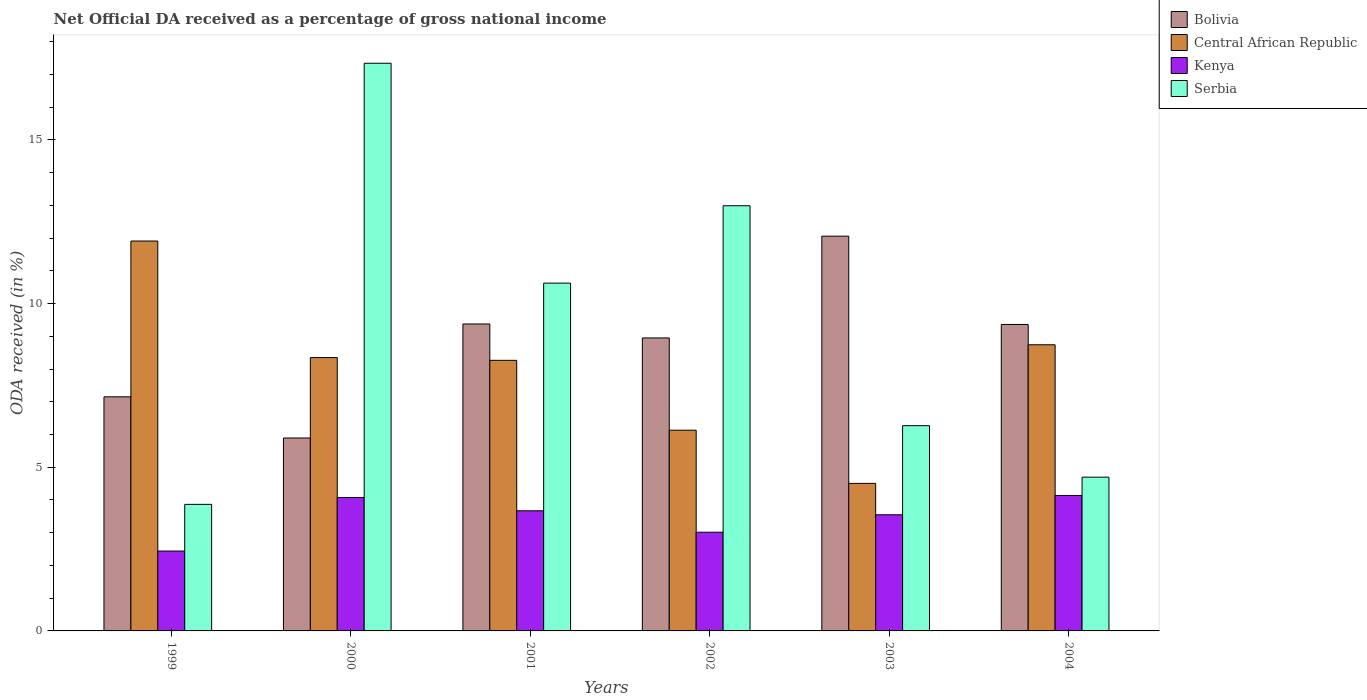How many different coloured bars are there?
Your response must be concise. 4. How many bars are there on the 1st tick from the left?
Your answer should be very brief. 4. What is the label of the 3rd group of bars from the left?
Provide a succinct answer. 2001. In how many cases, is the number of bars for a given year not equal to the number of legend labels?
Provide a succinct answer. 0. What is the net official DA received in Serbia in 2004?
Provide a succinct answer. 4.7. Across all years, what is the maximum net official DA received in Central African Republic?
Your answer should be compact. 11.91. Across all years, what is the minimum net official DA received in Bolivia?
Ensure brevity in your answer.  5.89. In which year was the net official DA received in Central African Republic minimum?
Offer a very short reply. 2003. What is the total net official DA received in Central African Republic in the graph?
Your response must be concise. 47.91. What is the difference between the net official DA received in Bolivia in 2000 and that in 2002?
Make the answer very short. -3.06. What is the difference between the net official DA received in Central African Republic in 2003 and the net official DA received in Kenya in 1999?
Provide a succinct answer. 2.07. What is the average net official DA received in Central African Republic per year?
Your answer should be compact. 7.99. In the year 2000, what is the difference between the net official DA received in Bolivia and net official DA received in Central African Republic?
Make the answer very short. -2.46. What is the ratio of the net official DA received in Serbia in 2003 to that in 2004?
Your response must be concise. 1.33. Is the net official DA received in Central African Republic in 1999 less than that in 2001?
Provide a short and direct response. No. What is the difference between the highest and the second highest net official DA received in Kenya?
Ensure brevity in your answer.  0.06. What is the difference between the highest and the lowest net official DA received in Kenya?
Ensure brevity in your answer.  1.7. Is the sum of the net official DA received in Bolivia in 2000 and 2002 greater than the maximum net official DA received in Kenya across all years?
Your answer should be compact. Yes. Is it the case that in every year, the sum of the net official DA received in Serbia and net official DA received in Central African Republic is greater than the sum of net official DA received in Bolivia and net official DA received in Kenya?
Your answer should be compact. No. What does the 2nd bar from the left in 2003 represents?
Keep it short and to the point. Central African Republic. What does the 1st bar from the right in 2000 represents?
Provide a succinct answer. Serbia. Is it the case that in every year, the sum of the net official DA received in Serbia and net official DA received in Kenya is greater than the net official DA received in Bolivia?
Offer a very short reply. No. Are all the bars in the graph horizontal?
Keep it short and to the point. No. Are the values on the major ticks of Y-axis written in scientific E-notation?
Give a very brief answer. No. Does the graph contain any zero values?
Provide a short and direct response. No. Where does the legend appear in the graph?
Keep it short and to the point. Top right. How are the legend labels stacked?
Provide a short and direct response. Vertical. What is the title of the graph?
Keep it short and to the point. Net Official DA received as a percentage of gross national income. What is the label or title of the Y-axis?
Make the answer very short. ODA received (in %). What is the ODA received (in %) of Bolivia in 1999?
Keep it short and to the point. 7.15. What is the ODA received (in %) in Central African Republic in 1999?
Offer a terse response. 11.91. What is the ODA received (in %) in Kenya in 1999?
Your answer should be compact. 2.44. What is the ODA received (in %) in Serbia in 1999?
Make the answer very short. 3.87. What is the ODA received (in %) of Bolivia in 2000?
Provide a succinct answer. 5.89. What is the ODA received (in %) of Central African Republic in 2000?
Provide a short and direct response. 8.35. What is the ODA received (in %) of Kenya in 2000?
Offer a very short reply. 4.08. What is the ODA received (in %) of Serbia in 2000?
Your answer should be compact. 17.34. What is the ODA received (in %) of Bolivia in 2001?
Make the answer very short. 9.38. What is the ODA received (in %) in Central African Republic in 2001?
Provide a short and direct response. 8.27. What is the ODA received (in %) in Kenya in 2001?
Your response must be concise. 3.67. What is the ODA received (in %) in Serbia in 2001?
Your answer should be very brief. 10.63. What is the ODA received (in %) of Bolivia in 2002?
Make the answer very short. 8.95. What is the ODA received (in %) of Central African Republic in 2002?
Your answer should be compact. 6.13. What is the ODA received (in %) in Kenya in 2002?
Provide a succinct answer. 3.02. What is the ODA received (in %) of Serbia in 2002?
Give a very brief answer. 12.99. What is the ODA received (in %) in Bolivia in 2003?
Make the answer very short. 12.06. What is the ODA received (in %) of Central African Republic in 2003?
Make the answer very short. 4.51. What is the ODA received (in %) of Kenya in 2003?
Provide a succinct answer. 3.55. What is the ODA received (in %) of Serbia in 2003?
Keep it short and to the point. 6.27. What is the ODA received (in %) of Bolivia in 2004?
Provide a succinct answer. 9.36. What is the ODA received (in %) in Central African Republic in 2004?
Your answer should be compact. 8.74. What is the ODA received (in %) in Kenya in 2004?
Your answer should be very brief. 4.14. What is the ODA received (in %) in Serbia in 2004?
Provide a succinct answer. 4.7. Across all years, what is the maximum ODA received (in %) of Bolivia?
Your answer should be very brief. 12.06. Across all years, what is the maximum ODA received (in %) of Central African Republic?
Keep it short and to the point. 11.91. Across all years, what is the maximum ODA received (in %) in Kenya?
Make the answer very short. 4.14. Across all years, what is the maximum ODA received (in %) of Serbia?
Provide a succinct answer. 17.34. Across all years, what is the minimum ODA received (in %) of Bolivia?
Keep it short and to the point. 5.89. Across all years, what is the minimum ODA received (in %) of Central African Republic?
Provide a succinct answer. 4.51. Across all years, what is the minimum ODA received (in %) in Kenya?
Ensure brevity in your answer.  2.44. Across all years, what is the minimum ODA received (in %) of Serbia?
Your answer should be compact. 3.87. What is the total ODA received (in %) of Bolivia in the graph?
Provide a succinct answer. 52.8. What is the total ODA received (in %) of Central African Republic in the graph?
Your answer should be very brief. 47.91. What is the total ODA received (in %) of Kenya in the graph?
Your answer should be very brief. 20.89. What is the total ODA received (in %) in Serbia in the graph?
Provide a short and direct response. 55.8. What is the difference between the ODA received (in %) of Bolivia in 1999 and that in 2000?
Make the answer very short. 1.26. What is the difference between the ODA received (in %) of Central African Republic in 1999 and that in 2000?
Give a very brief answer. 3.56. What is the difference between the ODA received (in %) of Kenya in 1999 and that in 2000?
Provide a short and direct response. -1.64. What is the difference between the ODA received (in %) in Serbia in 1999 and that in 2000?
Your response must be concise. -13.48. What is the difference between the ODA received (in %) in Bolivia in 1999 and that in 2001?
Your answer should be compact. -2.23. What is the difference between the ODA received (in %) in Central African Republic in 1999 and that in 2001?
Give a very brief answer. 3.65. What is the difference between the ODA received (in %) in Kenya in 1999 and that in 2001?
Keep it short and to the point. -1.23. What is the difference between the ODA received (in %) of Serbia in 1999 and that in 2001?
Your answer should be compact. -6.76. What is the difference between the ODA received (in %) of Bolivia in 1999 and that in 2002?
Make the answer very short. -1.8. What is the difference between the ODA received (in %) in Central African Republic in 1999 and that in 2002?
Your response must be concise. 5.78. What is the difference between the ODA received (in %) in Kenya in 1999 and that in 2002?
Offer a very short reply. -0.58. What is the difference between the ODA received (in %) in Serbia in 1999 and that in 2002?
Keep it short and to the point. -9.12. What is the difference between the ODA received (in %) in Bolivia in 1999 and that in 2003?
Offer a very short reply. -4.91. What is the difference between the ODA received (in %) in Central African Republic in 1999 and that in 2003?
Provide a succinct answer. 7.4. What is the difference between the ODA received (in %) of Kenya in 1999 and that in 2003?
Make the answer very short. -1.11. What is the difference between the ODA received (in %) in Serbia in 1999 and that in 2003?
Keep it short and to the point. -2.4. What is the difference between the ODA received (in %) of Bolivia in 1999 and that in 2004?
Offer a terse response. -2.21. What is the difference between the ODA received (in %) of Central African Republic in 1999 and that in 2004?
Make the answer very short. 3.17. What is the difference between the ODA received (in %) of Kenya in 1999 and that in 2004?
Your answer should be very brief. -1.7. What is the difference between the ODA received (in %) in Serbia in 1999 and that in 2004?
Make the answer very short. -0.83. What is the difference between the ODA received (in %) in Bolivia in 2000 and that in 2001?
Offer a very short reply. -3.48. What is the difference between the ODA received (in %) in Central African Republic in 2000 and that in 2001?
Provide a succinct answer. 0.08. What is the difference between the ODA received (in %) in Kenya in 2000 and that in 2001?
Give a very brief answer. 0.41. What is the difference between the ODA received (in %) in Serbia in 2000 and that in 2001?
Give a very brief answer. 6.72. What is the difference between the ODA received (in %) in Bolivia in 2000 and that in 2002?
Your answer should be very brief. -3.06. What is the difference between the ODA received (in %) of Central African Republic in 2000 and that in 2002?
Offer a very short reply. 2.22. What is the difference between the ODA received (in %) in Kenya in 2000 and that in 2002?
Offer a terse response. 1.06. What is the difference between the ODA received (in %) of Serbia in 2000 and that in 2002?
Provide a short and direct response. 4.35. What is the difference between the ODA received (in %) in Bolivia in 2000 and that in 2003?
Offer a very short reply. -6.17. What is the difference between the ODA received (in %) of Central African Republic in 2000 and that in 2003?
Offer a terse response. 3.84. What is the difference between the ODA received (in %) of Kenya in 2000 and that in 2003?
Your answer should be compact. 0.53. What is the difference between the ODA received (in %) in Serbia in 2000 and that in 2003?
Your response must be concise. 11.07. What is the difference between the ODA received (in %) in Bolivia in 2000 and that in 2004?
Your answer should be compact. -3.47. What is the difference between the ODA received (in %) of Central African Republic in 2000 and that in 2004?
Offer a very short reply. -0.39. What is the difference between the ODA received (in %) in Kenya in 2000 and that in 2004?
Keep it short and to the point. -0.06. What is the difference between the ODA received (in %) of Serbia in 2000 and that in 2004?
Your response must be concise. 12.65. What is the difference between the ODA received (in %) in Bolivia in 2001 and that in 2002?
Ensure brevity in your answer.  0.43. What is the difference between the ODA received (in %) in Central African Republic in 2001 and that in 2002?
Keep it short and to the point. 2.13. What is the difference between the ODA received (in %) in Kenya in 2001 and that in 2002?
Offer a terse response. 0.65. What is the difference between the ODA received (in %) in Serbia in 2001 and that in 2002?
Your response must be concise. -2.36. What is the difference between the ODA received (in %) in Bolivia in 2001 and that in 2003?
Offer a terse response. -2.68. What is the difference between the ODA received (in %) in Central African Republic in 2001 and that in 2003?
Offer a very short reply. 3.76. What is the difference between the ODA received (in %) of Kenya in 2001 and that in 2003?
Your response must be concise. 0.12. What is the difference between the ODA received (in %) in Serbia in 2001 and that in 2003?
Provide a succinct answer. 4.36. What is the difference between the ODA received (in %) of Bolivia in 2001 and that in 2004?
Offer a very short reply. 0.02. What is the difference between the ODA received (in %) of Central African Republic in 2001 and that in 2004?
Give a very brief answer. -0.48. What is the difference between the ODA received (in %) in Kenya in 2001 and that in 2004?
Provide a succinct answer. -0.47. What is the difference between the ODA received (in %) in Serbia in 2001 and that in 2004?
Give a very brief answer. 5.93. What is the difference between the ODA received (in %) of Bolivia in 2002 and that in 2003?
Ensure brevity in your answer.  -3.11. What is the difference between the ODA received (in %) in Central African Republic in 2002 and that in 2003?
Your response must be concise. 1.62. What is the difference between the ODA received (in %) of Kenya in 2002 and that in 2003?
Your answer should be very brief. -0.53. What is the difference between the ODA received (in %) of Serbia in 2002 and that in 2003?
Provide a short and direct response. 6.72. What is the difference between the ODA received (in %) in Bolivia in 2002 and that in 2004?
Your answer should be very brief. -0.41. What is the difference between the ODA received (in %) of Central African Republic in 2002 and that in 2004?
Make the answer very short. -2.61. What is the difference between the ODA received (in %) in Kenya in 2002 and that in 2004?
Keep it short and to the point. -1.12. What is the difference between the ODA received (in %) in Serbia in 2002 and that in 2004?
Give a very brief answer. 8.29. What is the difference between the ODA received (in %) in Bolivia in 2003 and that in 2004?
Provide a short and direct response. 2.7. What is the difference between the ODA received (in %) of Central African Republic in 2003 and that in 2004?
Your response must be concise. -4.24. What is the difference between the ODA received (in %) of Kenya in 2003 and that in 2004?
Offer a terse response. -0.59. What is the difference between the ODA received (in %) in Serbia in 2003 and that in 2004?
Ensure brevity in your answer.  1.57. What is the difference between the ODA received (in %) of Bolivia in 1999 and the ODA received (in %) of Central African Republic in 2000?
Make the answer very short. -1.2. What is the difference between the ODA received (in %) in Bolivia in 1999 and the ODA received (in %) in Kenya in 2000?
Provide a succinct answer. 3.08. What is the difference between the ODA received (in %) in Bolivia in 1999 and the ODA received (in %) in Serbia in 2000?
Provide a succinct answer. -10.19. What is the difference between the ODA received (in %) of Central African Republic in 1999 and the ODA received (in %) of Kenya in 2000?
Offer a terse response. 7.84. What is the difference between the ODA received (in %) of Central African Republic in 1999 and the ODA received (in %) of Serbia in 2000?
Provide a short and direct response. -5.43. What is the difference between the ODA received (in %) in Kenya in 1999 and the ODA received (in %) in Serbia in 2000?
Your answer should be very brief. -14.9. What is the difference between the ODA received (in %) of Bolivia in 1999 and the ODA received (in %) of Central African Republic in 2001?
Offer a very short reply. -1.11. What is the difference between the ODA received (in %) in Bolivia in 1999 and the ODA received (in %) in Kenya in 2001?
Your response must be concise. 3.48. What is the difference between the ODA received (in %) in Bolivia in 1999 and the ODA received (in %) in Serbia in 2001?
Provide a succinct answer. -3.47. What is the difference between the ODA received (in %) in Central African Republic in 1999 and the ODA received (in %) in Kenya in 2001?
Make the answer very short. 8.24. What is the difference between the ODA received (in %) of Central African Republic in 1999 and the ODA received (in %) of Serbia in 2001?
Provide a succinct answer. 1.29. What is the difference between the ODA received (in %) of Kenya in 1999 and the ODA received (in %) of Serbia in 2001?
Offer a terse response. -8.19. What is the difference between the ODA received (in %) of Bolivia in 1999 and the ODA received (in %) of Central African Republic in 2002?
Your answer should be very brief. 1.02. What is the difference between the ODA received (in %) in Bolivia in 1999 and the ODA received (in %) in Kenya in 2002?
Your response must be concise. 4.14. What is the difference between the ODA received (in %) of Bolivia in 1999 and the ODA received (in %) of Serbia in 2002?
Your answer should be very brief. -5.84. What is the difference between the ODA received (in %) of Central African Republic in 1999 and the ODA received (in %) of Kenya in 2002?
Your response must be concise. 8.9. What is the difference between the ODA received (in %) in Central African Republic in 1999 and the ODA received (in %) in Serbia in 2002?
Ensure brevity in your answer.  -1.08. What is the difference between the ODA received (in %) in Kenya in 1999 and the ODA received (in %) in Serbia in 2002?
Provide a short and direct response. -10.55. What is the difference between the ODA received (in %) in Bolivia in 1999 and the ODA received (in %) in Central African Republic in 2003?
Make the answer very short. 2.64. What is the difference between the ODA received (in %) of Bolivia in 1999 and the ODA received (in %) of Kenya in 2003?
Offer a terse response. 3.6. What is the difference between the ODA received (in %) of Bolivia in 1999 and the ODA received (in %) of Serbia in 2003?
Offer a terse response. 0.88. What is the difference between the ODA received (in %) of Central African Republic in 1999 and the ODA received (in %) of Kenya in 2003?
Provide a short and direct response. 8.36. What is the difference between the ODA received (in %) of Central African Republic in 1999 and the ODA received (in %) of Serbia in 2003?
Offer a very short reply. 5.64. What is the difference between the ODA received (in %) in Kenya in 1999 and the ODA received (in %) in Serbia in 2003?
Your answer should be very brief. -3.83. What is the difference between the ODA received (in %) of Bolivia in 1999 and the ODA received (in %) of Central African Republic in 2004?
Offer a terse response. -1.59. What is the difference between the ODA received (in %) in Bolivia in 1999 and the ODA received (in %) in Kenya in 2004?
Ensure brevity in your answer.  3.01. What is the difference between the ODA received (in %) of Bolivia in 1999 and the ODA received (in %) of Serbia in 2004?
Offer a very short reply. 2.45. What is the difference between the ODA received (in %) of Central African Republic in 1999 and the ODA received (in %) of Kenya in 2004?
Make the answer very short. 7.77. What is the difference between the ODA received (in %) in Central African Republic in 1999 and the ODA received (in %) in Serbia in 2004?
Give a very brief answer. 7.21. What is the difference between the ODA received (in %) of Kenya in 1999 and the ODA received (in %) of Serbia in 2004?
Offer a terse response. -2.26. What is the difference between the ODA received (in %) in Bolivia in 2000 and the ODA received (in %) in Central African Republic in 2001?
Keep it short and to the point. -2.37. What is the difference between the ODA received (in %) in Bolivia in 2000 and the ODA received (in %) in Kenya in 2001?
Provide a short and direct response. 2.22. What is the difference between the ODA received (in %) in Bolivia in 2000 and the ODA received (in %) in Serbia in 2001?
Provide a succinct answer. -4.73. What is the difference between the ODA received (in %) in Central African Republic in 2000 and the ODA received (in %) in Kenya in 2001?
Provide a succinct answer. 4.68. What is the difference between the ODA received (in %) in Central African Republic in 2000 and the ODA received (in %) in Serbia in 2001?
Provide a succinct answer. -2.28. What is the difference between the ODA received (in %) in Kenya in 2000 and the ODA received (in %) in Serbia in 2001?
Ensure brevity in your answer.  -6.55. What is the difference between the ODA received (in %) in Bolivia in 2000 and the ODA received (in %) in Central African Republic in 2002?
Make the answer very short. -0.24. What is the difference between the ODA received (in %) in Bolivia in 2000 and the ODA received (in %) in Kenya in 2002?
Provide a short and direct response. 2.88. What is the difference between the ODA received (in %) in Bolivia in 2000 and the ODA received (in %) in Serbia in 2002?
Your answer should be compact. -7.1. What is the difference between the ODA received (in %) of Central African Republic in 2000 and the ODA received (in %) of Kenya in 2002?
Offer a terse response. 5.34. What is the difference between the ODA received (in %) in Central African Republic in 2000 and the ODA received (in %) in Serbia in 2002?
Provide a succinct answer. -4.64. What is the difference between the ODA received (in %) of Kenya in 2000 and the ODA received (in %) of Serbia in 2002?
Offer a terse response. -8.91. What is the difference between the ODA received (in %) of Bolivia in 2000 and the ODA received (in %) of Central African Republic in 2003?
Provide a succinct answer. 1.39. What is the difference between the ODA received (in %) in Bolivia in 2000 and the ODA received (in %) in Kenya in 2003?
Provide a succinct answer. 2.35. What is the difference between the ODA received (in %) in Bolivia in 2000 and the ODA received (in %) in Serbia in 2003?
Offer a very short reply. -0.38. What is the difference between the ODA received (in %) of Central African Republic in 2000 and the ODA received (in %) of Kenya in 2003?
Make the answer very short. 4.8. What is the difference between the ODA received (in %) in Central African Republic in 2000 and the ODA received (in %) in Serbia in 2003?
Offer a very short reply. 2.08. What is the difference between the ODA received (in %) of Kenya in 2000 and the ODA received (in %) of Serbia in 2003?
Provide a succinct answer. -2.19. What is the difference between the ODA received (in %) in Bolivia in 2000 and the ODA received (in %) in Central African Republic in 2004?
Provide a short and direct response. -2.85. What is the difference between the ODA received (in %) of Bolivia in 2000 and the ODA received (in %) of Kenya in 2004?
Your answer should be compact. 1.76. What is the difference between the ODA received (in %) in Bolivia in 2000 and the ODA received (in %) in Serbia in 2004?
Make the answer very short. 1.2. What is the difference between the ODA received (in %) in Central African Republic in 2000 and the ODA received (in %) in Kenya in 2004?
Offer a very short reply. 4.21. What is the difference between the ODA received (in %) of Central African Republic in 2000 and the ODA received (in %) of Serbia in 2004?
Keep it short and to the point. 3.65. What is the difference between the ODA received (in %) of Kenya in 2000 and the ODA received (in %) of Serbia in 2004?
Ensure brevity in your answer.  -0.62. What is the difference between the ODA received (in %) in Bolivia in 2001 and the ODA received (in %) in Central African Republic in 2002?
Provide a succinct answer. 3.25. What is the difference between the ODA received (in %) of Bolivia in 2001 and the ODA received (in %) of Kenya in 2002?
Your answer should be compact. 6.36. What is the difference between the ODA received (in %) of Bolivia in 2001 and the ODA received (in %) of Serbia in 2002?
Keep it short and to the point. -3.61. What is the difference between the ODA received (in %) in Central African Republic in 2001 and the ODA received (in %) in Kenya in 2002?
Your answer should be very brief. 5.25. What is the difference between the ODA received (in %) of Central African Republic in 2001 and the ODA received (in %) of Serbia in 2002?
Ensure brevity in your answer.  -4.72. What is the difference between the ODA received (in %) of Kenya in 2001 and the ODA received (in %) of Serbia in 2002?
Provide a short and direct response. -9.32. What is the difference between the ODA received (in %) of Bolivia in 2001 and the ODA received (in %) of Central African Republic in 2003?
Your answer should be compact. 4.87. What is the difference between the ODA received (in %) in Bolivia in 2001 and the ODA received (in %) in Kenya in 2003?
Provide a short and direct response. 5.83. What is the difference between the ODA received (in %) of Bolivia in 2001 and the ODA received (in %) of Serbia in 2003?
Give a very brief answer. 3.11. What is the difference between the ODA received (in %) of Central African Republic in 2001 and the ODA received (in %) of Kenya in 2003?
Give a very brief answer. 4.72. What is the difference between the ODA received (in %) of Central African Republic in 2001 and the ODA received (in %) of Serbia in 2003?
Ensure brevity in your answer.  2. What is the difference between the ODA received (in %) in Kenya in 2001 and the ODA received (in %) in Serbia in 2003?
Provide a short and direct response. -2.6. What is the difference between the ODA received (in %) in Bolivia in 2001 and the ODA received (in %) in Central African Republic in 2004?
Keep it short and to the point. 0.64. What is the difference between the ODA received (in %) in Bolivia in 2001 and the ODA received (in %) in Kenya in 2004?
Provide a short and direct response. 5.24. What is the difference between the ODA received (in %) of Bolivia in 2001 and the ODA received (in %) of Serbia in 2004?
Your answer should be compact. 4.68. What is the difference between the ODA received (in %) of Central African Republic in 2001 and the ODA received (in %) of Kenya in 2004?
Your response must be concise. 4.13. What is the difference between the ODA received (in %) of Central African Republic in 2001 and the ODA received (in %) of Serbia in 2004?
Your answer should be compact. 3.57. What is the difference between the ODA received (in %) in Kenya in 2001 and the ODA received (in %) in Serbia in 2004?
Ensure brevity in your answer.  -1.03. What is the difference between the ODA received (in %) in Bolivia in 2002 and the ODA received (in %) in Central African Republic in 2003?
Give a very brief answer. 4.44. What is the difference between the ODA received (in %) in Bolivia in 2002 and the ODA received (in %) in Kenya in 2003?
Give a very brief answer. 5.4. What is the difference between the ODA received (in %) in Bolivia in 2002 and the ODA received (in %) in Serbia in 2003?
Provide a succinct answer. 2.68. What is the difference between the ODA received (in %) in Central African Republic in 2002 and the ODA received (in %) in Kenya in 2003?
Your answer should be compact. 2.58. What is the difference between the ODA received (in %) in Central African Republic in 2002 and the ODA received (in %) in Serbia in 2003?
Keep it short and to the point. -0.14. What is the difference between the ODA received (in %) in Kenya in 2002 and the ODA received (in %) in Serbia in 2003?
Provide a short and direct response. -3.26. What is the difference between the ODA received (in %) in Bolivia in 2002 and the ODA received (in %) in Central African Republic in 2004?
Your response must be concise. 0.21. What is the difference between the ODA received (in %) of Bolivia in 2002 and the ODA received (in %) of Kenya in 2004?
Make the answer very short. 4.81. What is the difference between the ODA received (in %) of Bolivia in 2002 and the ODA received (in %) of Serbia in 2004?
Offer a terse response. 4.25. What is the difference between the ODA received (in %) of Central African Republic in 2002 and the ODA received (in %) of Kenya in 2004?
Offer a terse response. 1.99. What is the difference between the ODA received (in %) of Central African Republic in 2002 and the ODA received (in %) of Serbia in 2004?
Give a very brief answer. 1.44. What is the difference between the ODA received (in %) of Kenya in 2002 and the ODA received (in %) of Serbia in 2004?
Your response must be concise. -1.68. What is the difference between the ODA received (in %) of Bolivia in 2003 and the ODA received (in %) of Central African Republic in 2004?
Offer a very short reply. 3.32. What is the difference between the ODA received (in %) in Bolivia in 2003 and the ODA received (in %) in Kenya in 2004?
Your answer should be very brief. 7.92. What is the difference between the ODA received (in %) in Bolivia in 2003 and the ODA received (in %) in Serbia in 2004?
Keep it short and to the point. 7.36. What is the difference between the ODA received (in %) of Central African Republic in 2003 and the ODA received (in %) of Kenya in 2004?
Your answer should be very brief. 0.37. What is the difference between the ODA received (in %) in Central African Republic in 2003 and the ODA received (in %) in Serbia in 2004?
Give a very brief answer. -0.19. What is the difference between the ODA received (in %) in Kenya in 2003 and the ODA received (in %) in Serbia in 2004?
Give a very brief answer. -1.15. What is the average ODA received (in %) of Bolivia per year?
Give a very brief answer. 8.8. What is the average ODA received (in %) in Central African Republic per year?
Your answer should be very brief. 7.99. What is the average ODA received (in %) of Kenya per year?
Offer a very short reply. 3.48. What is the average ODA received (in %) in Serbia per year?
Keep it short and to the point. 9.3. In the year 1999, what is the difference between the ODA received (in %) of Bolivia and ODA received (in %) of Central African Republic?
Give a very brief answer. -4.76. In the year 1999, what is the difference between the ODA received (in %) of Bolivia and ODA received (in %) of Kenya?
Give a very brief answer. 4.71. In the year 1999, what is the difference between the ODA received (in %) of Bolivia and ODA received (in %) of Serbia?
Make the answer very short. 3.29. In the year 1999, what is the difference between the ODA received (in %) of Central African Republic and ODA received (in %) of Kenya?
Offer a very short reply. 9.47. In the year 1999, what is the difference between the ODA received (in %) of Central African Republic and ODA received (in %) of Serbia?
Offer a terse response. 8.05. In the year 1999, what is the difference between the ODA received (in %) in Kenya and ODA received (in %) in Serbia?
Make the answer very short. -1.43. In the year 2000, what is the difference between the ODA received (in %) in Bolivia and ODA received (in %) in Central African Republic?
Offer a terse response. -2.46. In the year 2000, what is the difference between the ODA received (in %) of Bolivia and ODA received (in %) of Kenya?
Your response must be concise. 1.82. In the year 2000, what is the difference between the ODA received (in %) of Bolivia and ODA received (in %) of Serbia?
Your response must be concise. -11.45. In the year 2000, what is the difference between the ODA received (in %) in Central African Republic and ODA received (in %) in Kenya?
Keep it short and to the point. 4.27. In the year 2000, what is the difference between the ODA received (in %) in Central African Republic and ODA received (in %) in Serbia?
Keep it short and to the point. -8.99. In the year 2000, what is the difference between the ODA received (in %) of Kenya and ODA received (in %) of Serbia?
Keep it short and to the point. -13.27. In the year 2001, what is the difference between the ODA received (in %) of Bolivia and ODA received (in %) of Central African Republic?
Offer a terse response. 1.11. In the year 2001, what is the difference between the ODA received (in %) in Bolivia and ODA received (in %) in Kenya?
Provide a succinct answer. 5.71. In the year 2001, what is the difference between the ODA received (in %) of Bolivia and ODA received (in %) of Serbia?
Make the answer very short. -1.25. In the year 2001, what is the difference between the ODA received (in %) of Central African Republic and ODA received (in %) of Kenya?
Your response must be concise. 4.6. In the year 2001, what is the difference between the ODA received (in %) of Central African Republic and ODA received (in %) of Serbia?
Give a very brief answer. -2.36. In the year 2001, what is the difference between the ODA received (in %) in Kenya and ODA received (in %) in Serbia?
Make the answer very short. -6.96. In the year 2002, what is the difference between the ODA received (in %) of Bolivia and ODA received (in %) of Central African Republic?
Provide a short and direct response. 2.82. In the year 2002, what is the difference between the ODA received (in %) in Bolivia and ODA received (in %) in Kenya?
Keep it short and to the point. 5.94. In the year 2002, what is the difference between the ODA received (in %) of Bolivia and ODA received (in %) of Serbia?
Offer a very short reply. -4.04. In the year 2002, what is the difference between the ODA received (in %) of Central African Republic and ODA received (in %) of Kenya?
Give a very brief answer. 3.12. In the year 2002, what is the difference between the ODA received (in %) in Central African Republic and ODA received (in %) in Serbia?
Ensure brevity in your answer.  -6.86. In the year 2002, what is the difference between the ODA received (in %) of Kenya and ODA received (in %) of Serbia?
Your answer should be very brief. -9.97. In the year 2003, what is the difference between the ODA received (in %) of Bolivia and ODA received (in %) of Central African Republic?
Your answer should be very brief. 7.55. In the year 2003, what is the difference between the ODA received (in %) of Bolivia and ODA received (in %) of Kenya?
Provide a short and direct response. 8.51. In the year 2003, what is the difference between the ODA received (in %) of Bolivia and ODA received (in %) of Serbia?
Provide a short and direct response. 5.79. In the year 2003, what is the difference between the ODA received (in %) in Central African Republic and ODA received (in %) in Kenya?
Your response must be concise. 0.96. In the year 2003, what is the difference between the ODA received (in %) of Central African Republic and ODA received (in %) of Serbia?
Give a very brief answer. -1.76. In the year 2003, what is the difference between the ODA received (in %) in Kenya and ODA received (in %) in Serbia?
Give a very brief answer. -2.72. In the year 2004, what is the difference between the ODA received (in %) of Bolivia and ODA received (in %) of Central African Republic?
Ensure brevity in your answer.  0.62. In the year 2004, what is the difference between the ODA received (in %) in Bolivia and ODA received (in %) in Kenya?
Make the answer very short. 5.22. In the year 2004, what is the difference between the ODA received (in %) of Bolivia and ODA received (in %) of Serbia?
Give a very brief answer. 4.67. In the year 2004, what is the difference between the ODA received (in %) in Central African Republic and ODA received (in %) in Kenya?
Ensure brevity in your answer.  4.6. In the year 2004, what is the difference between the ODA received (in %) in Central African Republic and ODA received (in %) in Serbia?
Offer a terse response. 4.05. In the year 2004, what is the difference between the ODA received (in %) in Kenya and ODA received (in %) in Serbia?
Provide a succinct answer. -0.56. What is the ratio of the ODA received (in %) of Bolivia in 1999 to that in 2000?
Provide a succinct answer. 1.21. What is the ratio of the ODA received (in %) in Central African Republic in 1999 to that in 2000?
Provide a short and direct response. 1.43. What is the ratio of the ODA received (in %) in Kenya in 1999 to that in 2000?
Ensure brevity in your answer.  0.6. What is the ratio of the ODA received (in %) in Serbia in 1999 to that in 2000?
Provide a short and direct response. 0.22. What is the ratio of the ODA received (in %) in Bolivia in 1999 to that in 2001?
Provide a short and direct response. 0.76. What is the ratio of the ODA received (in %) of Central African Republic in 1999 to that in 2001?
Your answer should be compact. 1.44. What is the ratio of the ODA received (in %) in Kenya in 1999 to that in 2001?
Your answer should be very brief. 0.66. What is the ratio of the ODA received (in %) of Serbia in 1999 to that in 2001?
Offer a very short reply. 0.36. What is the ratio of the ODA received (in %) in Bolivia in 1999 to that in 2002?
Offer a very short reply. 0.8. What is the ratio of the ODA received (in %) in Central African Republic in 1999 to that in 2002?
Provide a short and direct response. 1.94. What is the ratio of the ODA received (in %) in Kenya in 1999 to that in 2002?
Offer a terse response. 0.81. What is the ratio of the ODA received (in %) in Serbia in 1999 to that in 2002?
Provide a short and direct response. 0.3. What is the ratio of the ODA received (in %) in Bolivia in 1999 to that in 2003?
Offer a very short reply. 0.59. What is the ratio of the ODA received (in %) in Central African Republic in 1999 to that in 2003?
Keep it short and to the point. 2.64. What is the ratio of the ODA received (in %) in Kenya in 1999 to that in 2003?
Your answer should be compact. 0.69. What is the ratio of the ODA received (in %) of Serbia in 1999 to that in 2003?
Make the answer very short. 0.62. What is the ratio of the ODA received (in %) of Bolivia in 1999 to that in 2004?
Give a very brief answer. 0.76. What is the ratio of the ODA received (in %) in Central African Republic in 1999 to that in 2004?
Your response must be concise. 1.36. What is the ratio of the ODA received (in %) in Kenya in 1999 to that in 2004?
Provide a short and direct response. 0.59. What is the ratio of the ODA received (in %) of Serbia in 1999 to that in 2004?
Keep it short and to the point. 0.82. What is the ratio of the ODA received (in %) in Bolivia in 2000 to that in 2001?
Provide a short and direct response. 0.63. What is the ratio of the ODA received (in %) of Central African Republic in 2000 to that in 2001?
Your response must be concise. 1.01. What is the ratio of the ODA received (in %) of Kenya in 2000 to that in 2001?
Offer a very short reply. 1.11. What is the ratio of the ODA received (in %) of Serbia in 2000 to that in 2001?
Provide a succinct answer. 1.63. What is the ratio of the ODA received (in %) in Bolivia in 2000 to that in 2002?
Your answer should be very brief. 0.66. What is the ratio of the ODA received (in %) in Central African Republic in 2000 to that in 2002?
Your answer should be very brief. 1.36. What is the ratio of the ODA received (in %) in Kenya in 2000 to that in 2002?
Ensure brevity in your answer.  1.35. What is the ratio of the ODA received (in %) of Serbia in 2000 to that in 2002?
Provide a succinct answer. 1.34. What is the ratio of the ODA received (in %) of Bolivia in 2000 to that in 2003?
Your answer should be very brief. 0.49. What is the ratio of the ODA received (in %) in Central African Republic in 2000 to that in 2003?
Keep it short and to the point. 1.85. What is the ratio of the ODA received (in %) in Kenya in 2000 to that in 2003?
Your answer should be compact. 1.15. What is the ratio of the ODA received (in %) in Serbia in 2000 to that in 2003?
Your response must be concise. 2.77. What is the ratio of the ODA received (in %) in Bolivia in 2000 to that in 2004?
Ensure brevity in your answer.  0.63. What is the ratio of the ODA received (in %) in Central African Republic in 2000 to that in 2004?
Give a very brief answer. 0.96. What is the ratio of the ODA received (in %) of Kenya in 2000 to that in 2004?
Offer a very short reply. 0.99. What is the ratio of the ODA received (in %) of Serbia in 2000 to that in 2004?
Provide a succinct answer. 3.69. What is the ratio of the ODA received (in %) of Bolivia in 2001 to that in 2002?
Offer a very short reply. 1.05. What is the ratio of the ODA received (in %) of Central African Republic in 2001 to that in 2002?
Provide a short and direct response. 1.35. What is the ratio of the ODA received (in %) of Kenya in 2001 to that in 2002?
Your answer should be very brief. 1.22. What is the ratio of the ODA received (in %) in Serbia in 2001 to that in 2002?
Your answer should be compact. 0.82. What is the ratio of the ODA received (in %) in Bolivia in 2001 to that in 2003?
Keep it short and to the point. 0.78. What is the ratio of the ODA received (in %) of Central African Republic in 2001 to that in 2003?
Your answer should be compact. 1.83. What is the ratio of the ODA received (in %) in Kenya in 2001 to that in 2003?
Your response must be concise. 1.03. What is the ratio of the ODA received (in %) in Serbia in 2001 to that in 2003?
Provide a succinct answer. 1.69. What is the ratio of the ODA received (in %) of Bolivia in 2001 to that in 2004?
Keep it short and to the point. 1. What is the ratio of the ODA received (in %) of Central African Republic in 2001 to that in 2004?
Provide a short and direct response. 0.95. What is the ratio of the ODA received (in %) in Kenya in 2001 to that in 2004?
Provide a short and direct response. 0.89. What is the ratio of the ODA received (in %) of Serbia in 2001 to that in 2004?
Your answer should be compact. 2.26. What is the ratio of the ODA received (in %) of Bolivia in 2002 to that in 2003?
Keep it short and to the point. 0.74. What is the ratio of the ODA received (in %) of Central African Republic in 2002 to that in 2003?
Offer a very short reply. 1.36. What is the ratio of the ODA received (in %) in Kenya in 2002 to that in 2003?
Your response must be concise. 0.85. What is the ratio of the ODA received (in %) of Serbia in 2002 to that in 2003?
Provide a succinct answer. 2.07. What is the ratio of the ODA received (in %) in Bolivia in 2002 to that in 2004?
Keep it short and to the point. 0.96. What is the ratio of the ODA received (in %) of Central African Republic in 2002 to that in 2004?
Provide a short and direct response. 0.7. What is the ratio of the ODA received (in %) in Kenya in 2002 to that in 2004?
Provide a short and direct response. 0.73. What is the ratio of the ODA received (in %) in Serbia in 2002 to that in 2004?
Make the answer very short. 2.77. What is the ratio of the ODA received (in %) in Bolivia in 2003 to that in 2004?
Offer a terse response. 1.29. What is the ratio of the ODA received (in %) of Central African Republic in 2003 to that in 2004?
Provide a succinct answer. 0.52. What is the ratio of the ODA received (in %) in Kenya in 2003 to that in 2004?
Offer a very short reply. 0.86. What is the ratio of the ODA received (in %) of Serbia in 2003 to that in 2004?
Ensure brevity in your answer.  1.33. What is the difference between the highest and the second highest ODA received (in %) of Bolivia?
Provide a succinct answer. 2.68. What is the difference between the highest and the second highest ODA received (in %) in Central African Republic?
Provide a short and direct response. 3.17. What is the difference between the highest and the second highest ODA received (in %) of Kenya?
Provide a succinct answer. 0.06. What is the difference between the highest and the second highest ODA received (in %) in Serbia?
Provide a short and direct response. 4.35. What is the difference between the highest and the lowest ODA received (in %) of Bolivia?
Your response must be concise. 6.17. What is the difference between the highest and the lowest ODA received (in %) of Central African Republic?
Provide a short and direct response. 7.4. What is the difference between the highest and the lowest ODA received (in %) in Kenya?
Ensure brevity in your answer.  1.7. What is the difference between the highest and the lowest ODA received (in %) of Serbia?
Provide a short and direct response. 13.48. 